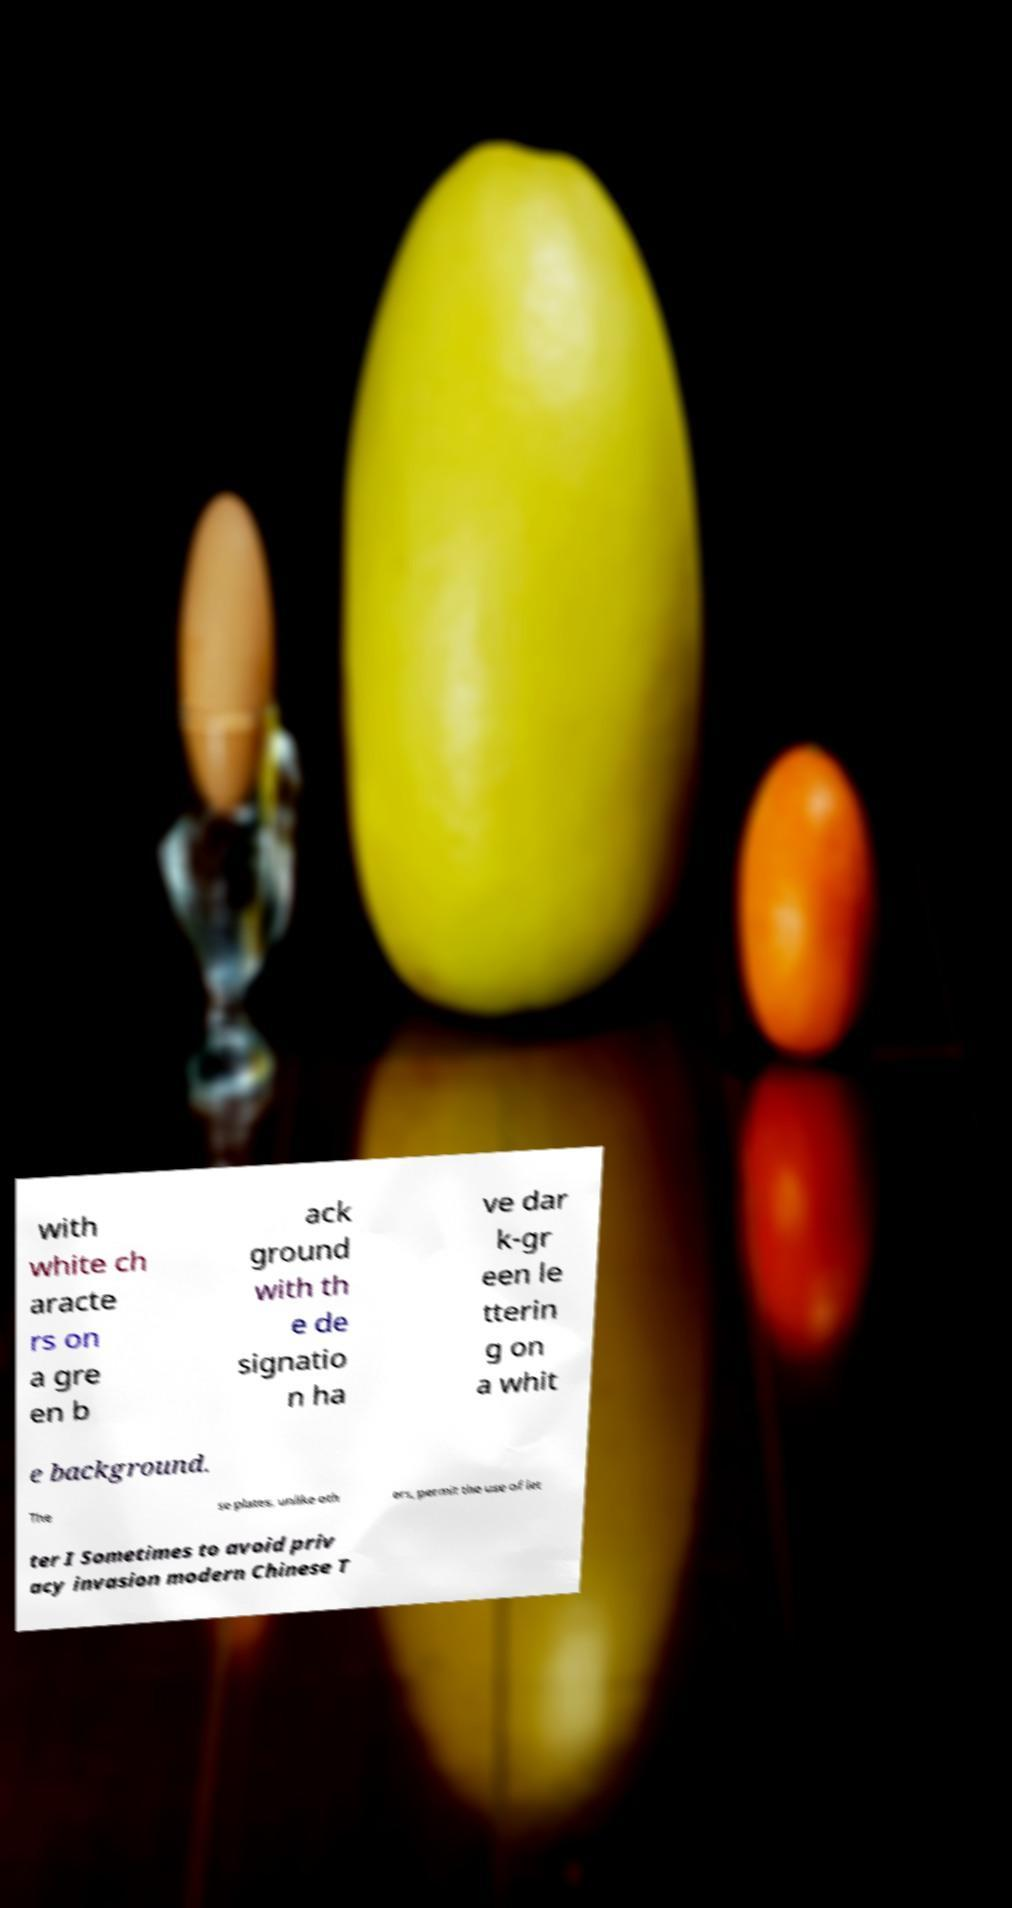There's text embedded in this image that I need extracted. Can you transcribe it verbatim? with white ch aracte rs on a gre en b ack ground with th e de signatio n ha ve dar k-gr een le tterin g on a whit e background. The se plates, unlike oth ers, permit the use of let ter I Sometimes to avoid priv acy invasion modern Chinese T 